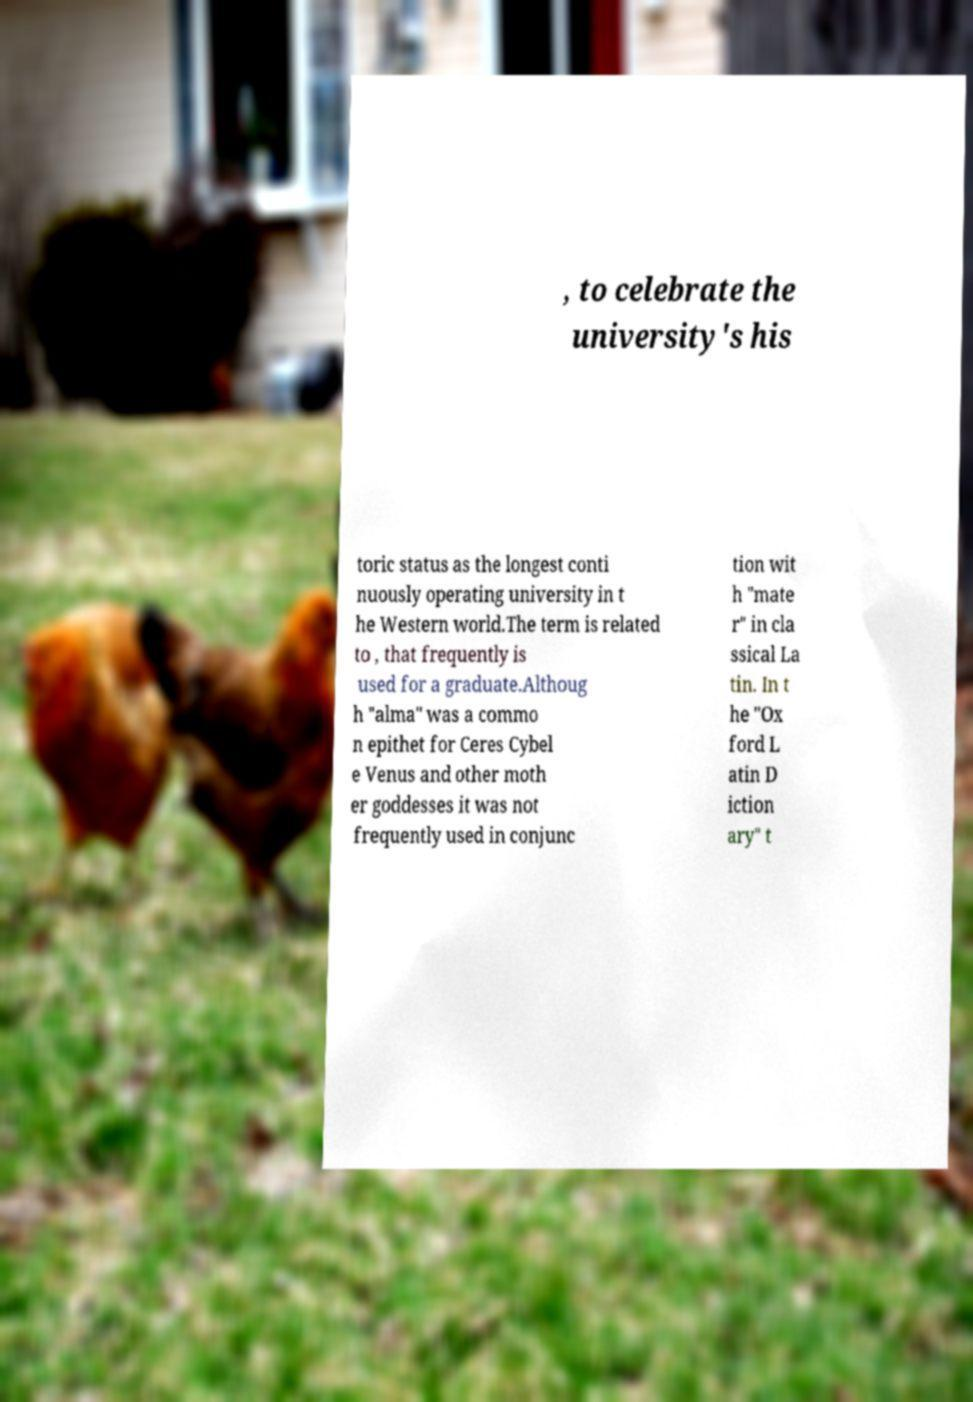Can you accurately transcribe the text from the provided image for me? , to celebrate the university's his toric status as the longest conti nuously operating university in t he Western world.The term is related to , that frequently is used for a graduate.Althoug h "alma" was a commo n epithet for Ceres Cybel e Venus and other moth er goddesses it was not frequently used in conjunc tion wit h "mate r" in cla ssical La tin. In t he "Ox ford L atin D iction ary" t 